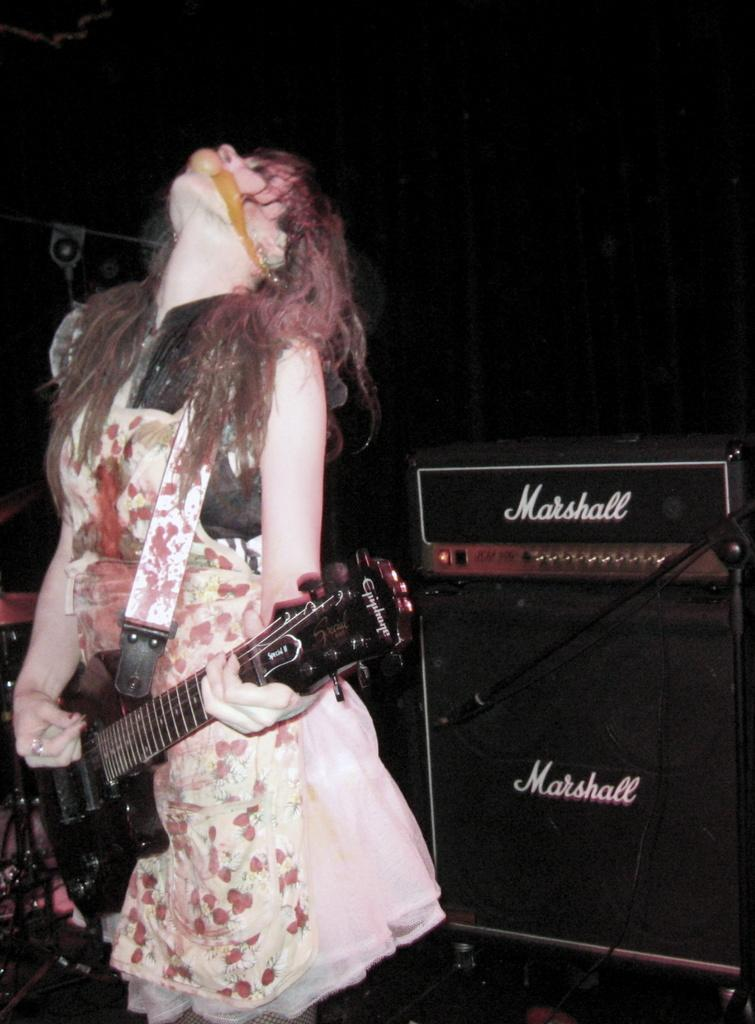What is the woman in the image doing? The woman is playing a guitar and singing. What instrument is the woman playing in the image? The woman is playing a guitar. Can you describe the background of the image? There is a speaker in the background of the image. How does the woman kick the ball while playing the guitar in the image? There is no ball present in the image, so the woman cannot kick it. 